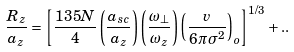<formula> <loc_0><loc_0><loc_500><loc_500>\frac { R _ { z } } { a _ { z } } = \left [ \frac { 1 3 5 N } { 4 } \left ( \frac { a _ { s c } } { a _ { z } } \right ) \left ( \frac { \omega _ { \perp } } { \omega _ { z } } \right ) \left ( \frac { v } { 6 \pi \sigma ^ { 2 } } \right ) _ { o } \right ] ^ { 1 / 3 } + . .</formula> 